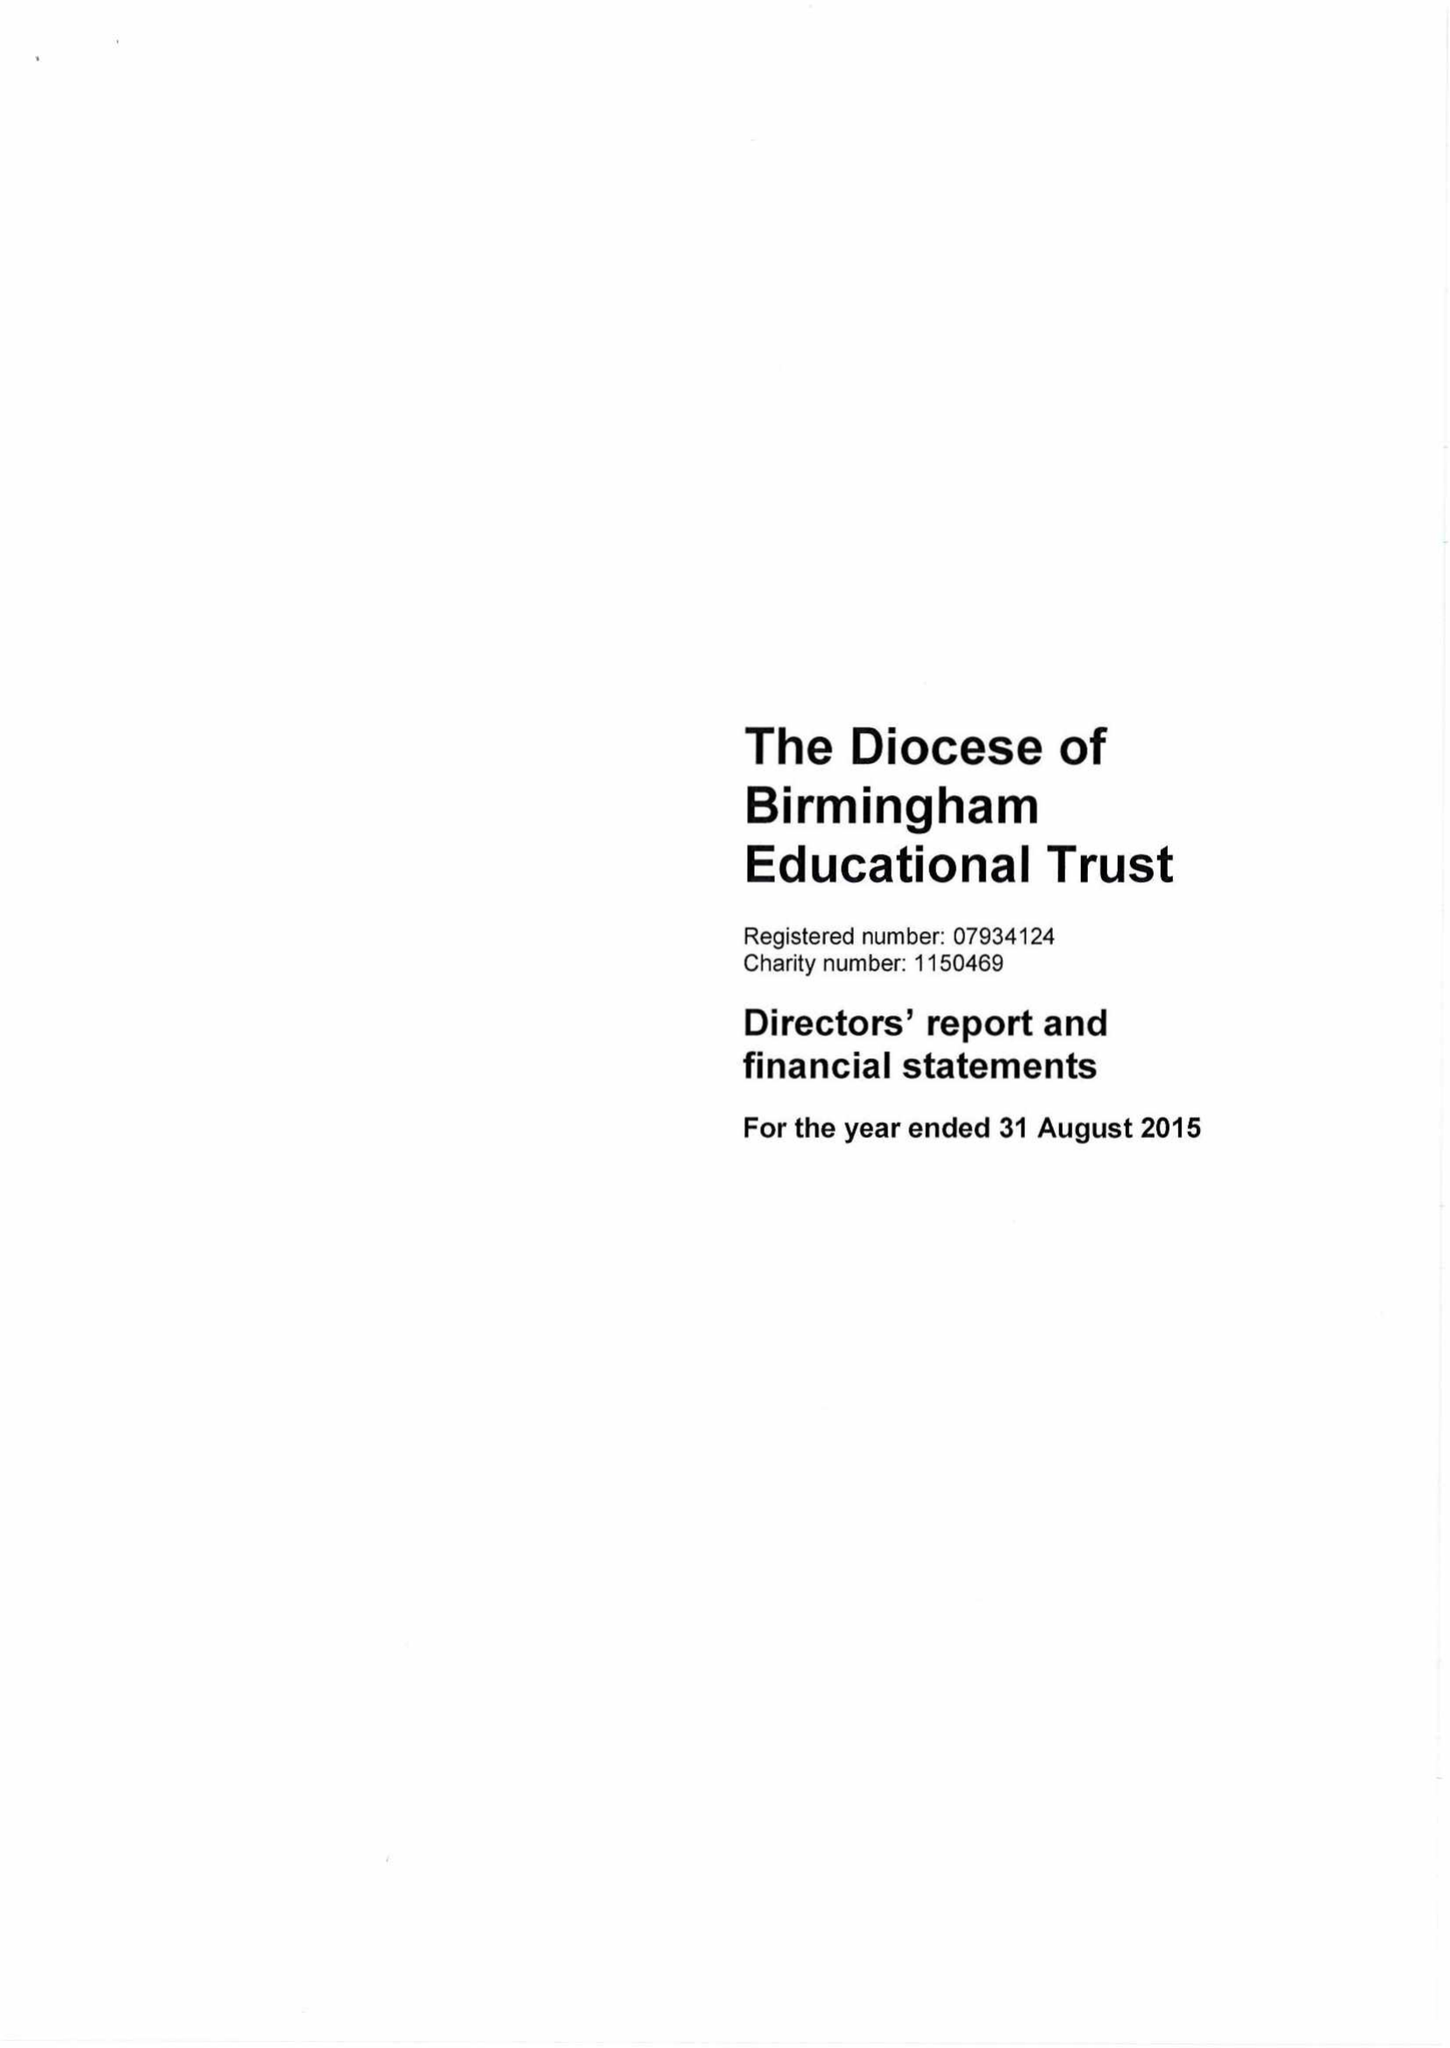What is the value for the report_date?
Answer the question using a single word or phrase. 2015-08-31 